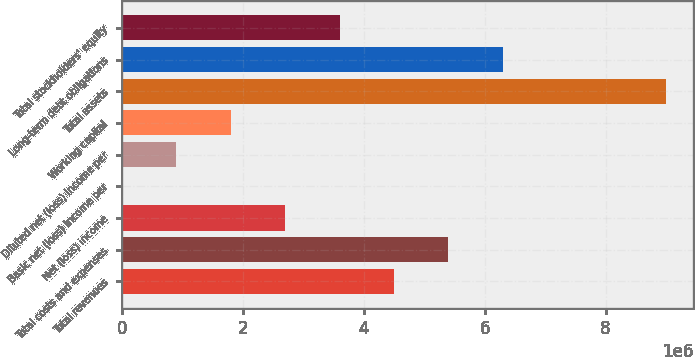Convert chart. <chart><loc_0><loc_0><loc_500><loc_500><bar_chart><fcel>Total revenues<fcel>Total costs and expenses<fcel>Net (loss) income<fcel>Basic net (loss) income per<fcel>Diluted net (loss) income per<fcel>Working capital<fcel>Total assets<fcel>Long-term debt obligations<fcel>Total stockholders' equity<nl><fcel>4.50041e+06<fcel>5.4005e+06<fcel>2.70025e+06<fcel>4.36<fcel>900086<fcel>1.80017e+06<fcel>9.00082e+06<fcel>6.30058e+06<fcel>3.60033e+06<nl></chart> 